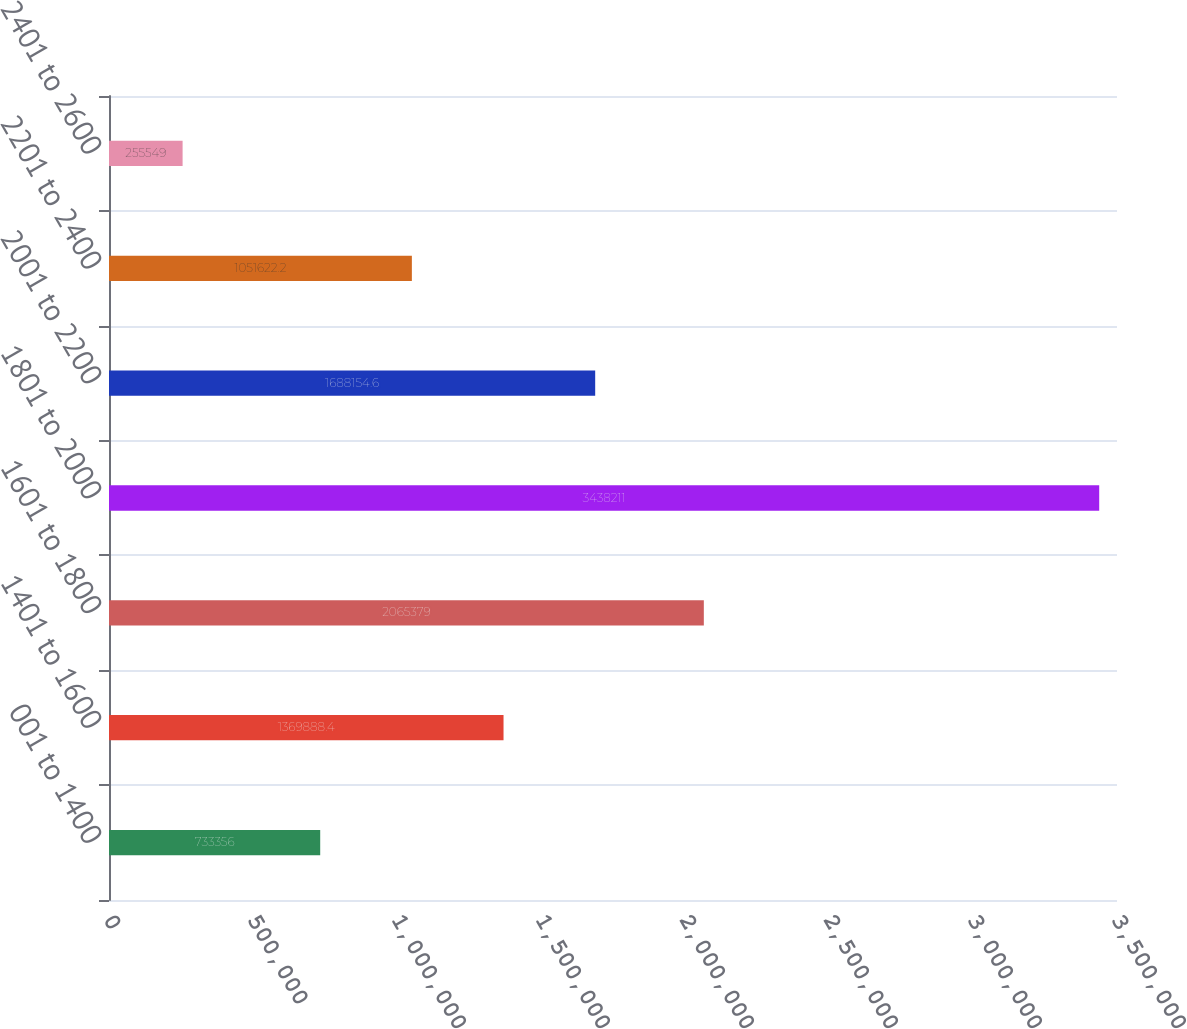Convert chart to OTSL. <chart><loc_0><loc_0><loc_500><loc_500><bar_chart><fcel>001 to 1400<fcel>1401 to 1600<fcel>1601 to 1800<fcel>1801 to 2000<fcel>2001 to 2200<fcel>2201 to 2400<fcel>2401 to 2600<nl><fcel>733356<fcel>1.36989e+06<fcel>2.06538e+06<fcel>3.43821e+06<fcel>1.68815e+06<fcel>1.05162e+06<fcel>255549<nl></chart> 